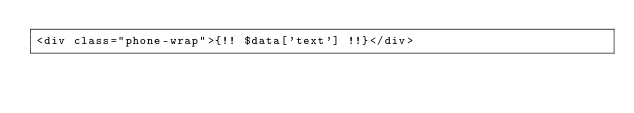Convert code to text. <code><loc_0><loc_0><loc_500><loc_500><_PHP_><div class="phone-wrap">{!! $data['text'] !!}</div></code> 